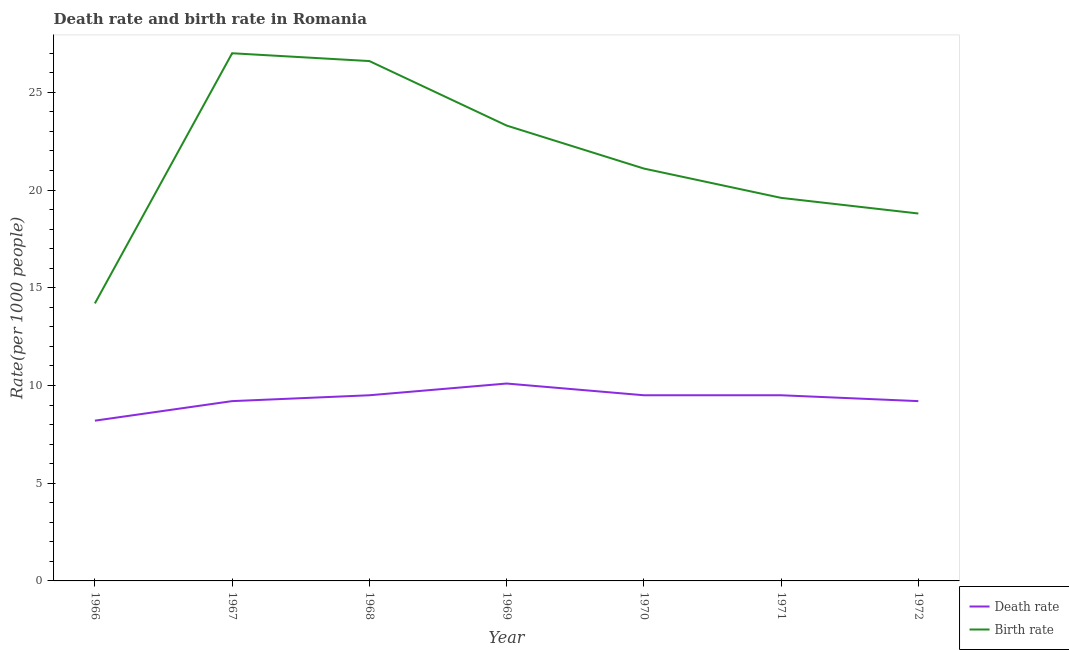Does the line corresponding to death rate intersect with the line corresponding to birth rate?
Ensure brevity in your answer.  No. Is the number of lines equal to the number of legend labels?
Give a very brief answer. Yes. In which year was the birth rate maximum?
Make the answer very short. 1967. In which year was the birth rate minimum?
Make the answer very short. 1966. What is the total death rate in the graph?
Offer a very short reply. 65.2. What is the difference between the birth rate in 1966 and that in 1971?
Offer a terse response. -5.4. What is the difference between the birth rate in 1972 and the death rate in 1970?
Give a very brief answer. 9.3. What is the average death rate per year?
Your answer should be very brief. 9.31. In the year 1971, what is the difference between the birth rate and death rate?
Your answer should be compact. 10.1. In how many years, is the birth rate greater than 19?
Keep it short and to the point. 5. What is the ratio of the birth rate in 1966 to that in 1970?
Offer a terse response. 0.67. Is the difference between the birth rate in 1966 and 1967 greater than the difference between the death rate in 1966 and 1967?
Provide a short and direct response. No. What is the difference between the highest and the second highest birth rate?
Provide a short and direct response. 0.4. What is the difference between the highest and the lowest death rate?
Offer a very short reply. 1.9. Does the death rate monotonically increase over the years?
Keep it short and to the point. No. What is the difference between two consecutive major ticks on the Y-axis?
Provide a succinct answer. 5. Where does the legend appear in the graph?
Your answer should be compact. Bottom right. How are the legend labels stacked?
Give a very brief answer. Vertical. What is the title of the graph?
Keep it short and to the point. Death rate and birth rate in Romania. What is the label or title of the X-axis?
Offer a terse response. Year. What is the label or title of the Y-axis?
Provide a succinct answer. Rate(per 1000 people). What is the Rate(per 1000 people) of Death rate in 1967?
Make the answer very short. 9.2. What is the Rate(per 1000 people) in Birth rate in 1967?
Offer a very short reply. 27. What is the Rate(per 1000 people) of Birth rate in 1968?
Give a very brief answer. 26.6. What is the Rate(per 1000 people) of Death rate in 1969?
Provide a succinct answer. 10.1. What is the Rate(per 1000 people) in Birth rate in 1969?
Offer a very short reply. 23.3. What is the Rate(per 1000 people) of Birth rate in 1970?
Ensure brevity in your answer.  21.1. What is the Rate(per 1000 people) of Birth rate in 1971?
Give a very brief answer. 19.6. What is the Rate(per 1000 people) of Birth rate in 1972?
Offer a very short reply. 18.8. Across all years, what is the minimum Rate(per 1000 people) in Death rate?
Ensure brevity in your answer.  8.2. What is the total Rate(per 1000 people) in Death rate in the graph?
Offer a very short reply. 65.2. What is the total Rate(per 1000 people) of Birth rate in the graph?
Keep it short and to the point. 150.6. What is the difference between the Rate(per 1000 people) of Birth rate in 1966 and that in 1967?
Your response must be concise. -12.8. What is the difference between the Rate(per 1000 people) in Death rate in 1966 and that in 1968?
Offer a terse response. -1.3. What is the difference between the Rate(per 1000 people) of Birth rate in 1966 and that in 1969?
Keep it short and to the point. -9.1. What is the difference between the Rate(per 1000 people) in Death rate in 1966 and that in 1970?
Offer a terse response. -1.3. What is the difference between the Rate(per 1000 people) in Birth rate in 1966 and that in 1970?
Ensure brevity in your answer.  -6.9. What is the difference between the Rate(per 1000 people) of Birth rate in 1966 and that in 1971?
Ensure brevity in your answer.  -5.4. What is the difference between the Rate(per 1000 people) of Death rate in 1966 and that in 1972?
Offer a very short reply. -1. What is the difference between the Rate(per 1000 people) of Birth rate in 1966 and that in 1972?
Ensure brevity in your answer.  -4.6. What is the difference between the Rate(per 1000 people) in Birth rate in 1967 and that in 1968?
Offer a very short reply. 0.4. What is the difference between the Rate(per 1000 people) in Death rate in 1967 and that in 1969?
Your answer should be compact. -0.9. What is the difference between the Rate(per 1000 people) in Birth rate in 1967 and that in 1969?
Give a very brief answer. 3.7. What is the difference between the Rate(per 1000 people) of Death rate in 1967 and that in 1970?
Offer a terse response. -0.3. What is the difference between the Rate(per 1000 people) of Birth rate in 1967 and that in 1970?
Provide a succinct answer. 5.9. What is the difference between the Rate(per 1000 people) of Death rate in 1967 and that in 1971?
Your answer should be compact. -0.3. What is the difference between the Rate(per 1000 people) in Birth rate in 1967 and that in 1971?
Offer a very short reply. 7.4. What is the difference between the Rate(per 1000 people) of Birth rate in 1968 and that in 1969?
Keep it short and to the point. 3.3. What is the difference between the Rate(per 1000 people) in Death rate in 1968 and that in 1972?
Offer a terse response. 0.3. What is the difference between the Rate(per 1000 people) of Birth rate in 1969 and that in 1970?
Make the answer very short. 2.2. What is the difference between the Rate(per 1000 people) of Birth rate in 1969 and that in 1971?
Keep it short and to the point. 3.7. What is the difference between the Rate(per 1000 people) of Death rate in 1969 and that in 1972?
Ensure brevity in your answer.  0.9. What is the difference between the Rate(per 1000 people) in Death rate in 1970 and that in 1972?
Keep it short and to the point. 0.3. What is the difference between the Rate(per 1000 people) of Birth rate in 1970 and that in 1972?
Ensure brevity in your answer.  2.3. What is the difference between the Rate(per 1000 people) of Death rate in 1971 and that in 1972?
Give a very brief answer. 0.3. What is the difference between the Rate(per 1000 people) in Birth rate in 1971 and that in 1972?
Your answer should be compact. 0.8. What is the difference between the Rate(per 1000 people) in Death rate in 1966 and the Rate(per 1000 people) in Birth rate in 1967?
Ensure brevity in your answer.  -18.8. What is the difference between the Rate(per 1000 people) in Death rate in 1966 and the Rate(per 1000 people) in Birth rate in 1968?
Give a very brief answer. -18.4. What is the difference between the Rate(per 1000 people) in Death rate in 1966 and the Rate(per 1000 people) in Birth rate in 1969?
Offer a terse response. -15.1. What is the difference between the Rate(per 1000 people) of Death rate in 1966 and the Rate(per 1000 people) of Birth rate in 1971?
Offer a very short reply. -11.4. What is the difference between the Rate(per 1000 people) in Death rate in 1967 and the Rate(per 1000 people) in Birth rate in 1968?
Your answer should be very brief. -17.4. What is the difference between the Rate(per 1000 people) in Death rate in 1967 and the Rate(per 1000 people) in Birth rate in 1969?
Offer a terse response. -14.1. What is the difference between the Rate(per 1000 people) of Death rate in 1967 and the Rate(per 1000 people) of Birth rate in 1970?
Your answer should be very brief. -11.9. What is the difference between the Rate(per 1000 people) in Death rate in 1967 and the Rate(per 1000 people) in Birth rate in 1971?
Offer a very short reply. -10.4. What is the difference between the Rate(per 1000 people) in Death rate in 1968 and the Rate(per 1000 people) in Birth rate in 1972?
Give a very brief answer. -9.3. What is the difference between the Rate(per 1000 people) in Death rate in 1969 and the Rate(per 1000 people) in Birth rate in 1970?
Ensure brevity in your answer.  -11. What is the difference between the Rate(per 1000 people) of Death rate in 1969 and the Rate(per 1000 people) of Birth rate in 1971?
Make the answer very short. -9.5. What is the difference between the Rate(per 1000 people) of Death rate in 1969 and the Rate(per 1000 people) of Birth rate in 1972?
Offer a terse response. -8.7. What is the difference between the Rate(per 1000 people) in Death rate in 1970 and the Rate(per 1000 people) in Birth rate in 1971?
Make the answer very short. -10.1. What is the difference between the Rate(per 1000 people) in Death rate in 1970 and the Rate(per 1000 people) in Birth rate in 1972?
Offer a terse response. -9.3. What is the average Rate(per 1000 people) in Death rate per year?
Provide a short and direct response. 9.31. What is the average Rate(per 1000 people) in Birth rate per year?
Keep it short and to the point. 21.51. In the year 1966, what is the difference between the Rate(per 1000 people) in Death rate and Rate(per 1000 people) in Birth rate?
Ensure brevity in your answer.  -6. In the year 1967, what is the difference between the Rate(per 1000 people) of Death rate and Rate(per 1000 people) of Birth rate?
Provide a succinct answer. -17.8. In the year 1968, what is the difference between the Rate(per 1000 people) of Death rate and Rate(per 1000 people) of Birth rate?
Give a very brief answer. -17.1. In the year 1969, what is the difference between the Rate(per 1000 people) of Death rate and Rate(per 1000 people) of Birth rate?
Provide a short and direct response. -13.2. What is the ratio of the Rate(per 1000 people) in Death rate in 1966 to that in 1967?
Keep it short and to the point. 0.89. What is the ratio of the Rate(per 1000 people) of Birth rate in 1966 to that in 1967?
Ensure brevity in your answer.  0.53. What is the ratio of the Rate(per 1000 people) of Death rate in 1966 to that in 1968?
Offer a very short reply. 0.86. What is the ratio of the Rate(per 1000 people) in Birth rate in 1966 to that in 1968?
Your answer should be very brief. 0.53. What is the ratio of the Rate(per 1000 people) in Death rate in 1966 to that in 1969?
Ensure brevity in your answer.  0.81. What is the ratio of the Rate(per 1000 people) in Birth rate in 1966 to that in 1969?
Make the answer very short. 0.61. What is the ratio of the Rate(per 1000 people) of Death rate in 1966 to that in 1970?
Provide a short and direct response. 0.86. What is the ratio of the Rate(per 1000 people) in Birth rate in 1966 to that in 1970?
Offer a very short reply. 0.67. What is the ratio of the Rate(per 1000 people) of Death rate in 1966 to that in 1971?
Your answer should be very brief. 0.86. What is the ratio of the Rate(per 1000 people) of Birth rate in 1966 to that in 1971?
Give a very brief answer. 0.72. What is the ratio of the Rate(per 1000 people) of Death rate in 1966 to that in 1972?
Provide a short and direct response. 0.89. What is the ratio of the Rate(per 1000 people) of Birth rate in 1966 to that in 1972?
Your answer should be very brief. 0.76. What is the ratio of the Rate(per 1000 people) of Death rate in 1967 to that in 1968?
Keep it short and to the point. 0.97. What is the ratio of the Rate(per 1000 people) of Death rate in 1967 to that in 1969?
Give a very brief answer. 0.91. What is the ratio of the Rate(per 1000 people) in Birth rate in 1967 to that in 1969?
Your answer should be compact. 1.16. What is the ratio of the Rate(per 1000 people) in Death rate in 1967 to that in 1970?
Offer a terse response. 0.97. What is the ratio of the Rate(per 1000 people) of Birth rate in 1967 to that in 1970?
Your answer should be very brief. 1.28. What is the ratio of the Rate(per 1000 people) of Death rate in 1967 to that in 1971?
Provide a short and direct response. 0.97. What is the ratio of the Rate(per 1000 people) of Birth rate in 1967 to that in 1971?
Ensure brevity in your answer.  1.38. What is the ratio of the Rate(per 1000 people) of Birth rate in 1967 to that in 1972?
Your answer should be very brief. 1.44. What is the ratio of the Rate(per 1000 people) of Death rate in 1968 to that in 1969?
Ensure brevity in your answer.  0.94. What is the ratio of the Rate(per 1000 people) in Birth rate in 1968 to that in 1969?
Provide a succinct answer. 1.14. What is the ratio of the Rate(per 1000 people) in Birth rate in 1968 to that in 1970?
Your answer should be compact. 1.26. What is the ratio of the Rate(per 1000 people) of Death rate in 1968 to that in 1971?
Your response must be concise. 1. What is the ratio of the Rate(per 1000 people) in Birth rate in 1968 to that in 1971?
Keep it short and to the point. 1.36. What is the ratio of the Rate(per 1000 people) of Death rate in 1968 to that in 1972?
Keep it short and to the point. 1.03. What is the ratio of the Rate(per 1000 people) of Birth rate in 1968 to that in 1972?
Provide a short and direct response. 1.41. What is the ratio of the Rate(per 1000 people) in Death rate in 1969 to that in 1970?
Make the answer very short. 1.06. What is the ratio of the Rate(per 1000 people) in Birth rate in 1969 to that in 1970?
Your response must be concise. 1.1. What is the ratio of the Rate(per 1000 people) of Death rate in 1969 to that in 1971?
Ensure brevity in your answer.  1.06. What is the ratio of the Rate(per 1000 people) of Birth rate in 1969 to that in 1971?
Your response must be concise. 1.19. What is the ratio of the Rate(per 1000 people) in Death rate in 1969 to that in 1972?
Your response must be concise. 1.1. What is the ratio of the Rate(per 1000 people) in Birth rate in 1969 to that in 1972?
Provide a succinct answer. 1.24. What is the ratio of the Rate(per 1000 people) in Death rate in 1970 to that in 1971?
Your answer should be compact. 1. What is the ratio of the Rate(per 1000 people) in Birth rate in 1970 to that in 1971?
Offer a terse response. 1.08. What is the ratio of the Rate(per 1000 people) in Death rate in 1970 to that in 1972?
Give a very brief answer. 1.03. What is the ratio of the Rate(per 1000 people) of Birth rate in 1970 to that in 1972?
Offer a very short reply. 1.12. What is the ratio of the Rate(per 1000 people) of Death rate in 1971 to that in 1972?
Make the answer very short. 1.03. What is the ratio of the Rate(per 1000 people) of Birth rate in 1971 to that in 1972?
Offer a terse response. 1.04. What is the difference between the highest and the second highest Rate(per 1000 people) in Birth rate?
Give a very brief answer. 0.4. 